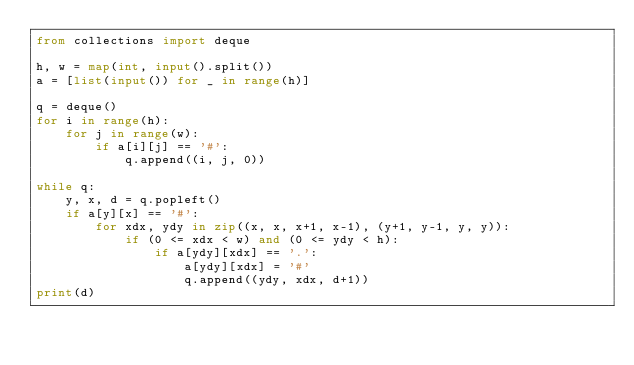Convert code to text. <code><loc_0><loc_0><loc_500><loc_500><_Python_>from collections import deque

h, w = map(int, input().split())
a = [list(input()) for _ in range(h)]

q = deque()
for i in range(h):
    for j in range(w):
        if a[i][j] == '#':
            q.append((i, j, 0)) 

while q:
    y, x, d = q.popleft()
    if a[y][x] == '#':
        for xdx, ydy in zip((x, x, x+1, x-1), (y+1, y-1, y, y)):
            if (0 <= xdx < w) and (0 <= ydy < h):
                if a[ydy][xdx] == '.':
                    a[ydy][xdx] = '#'
                    q.append((ydy, xdx, d+1))
print(d)</code> 